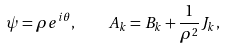<formula> <loc_0><loc_0><loc_500><loc_500>\psi = \rho e ^ { i \theta } , \quad A _ { k } = B _ { k } + \frac { 1 } { \rho ^ { 2 } } J _ { k } ,</formula> 